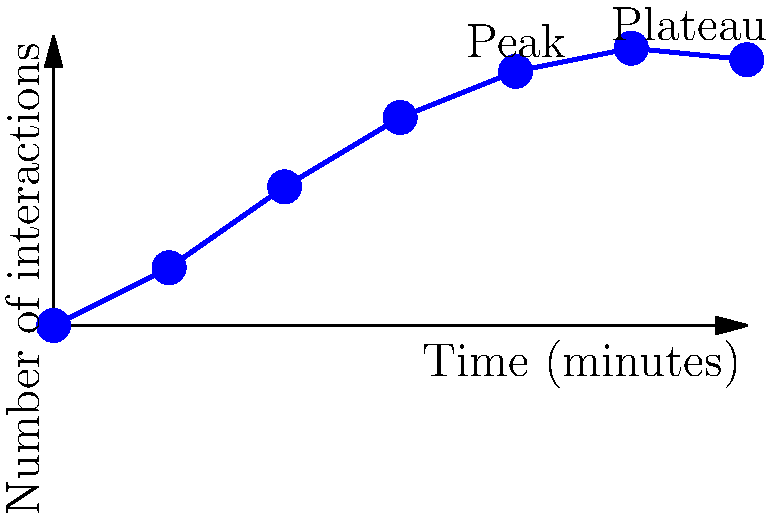Analyze the graph depicting social interactions among children in a playground over time. What psychological principle best explains the initial increase and subsequent plateau in social interactions? To answer this question, let's analyze the graph step-by-step:

1. Initial increase (0-40 minutes):
   - The number of social interactions rises rapidly from 0 to about 22.
   - This suggests children are becoming more comfortable in the environment and with each other.

2. Plateau (40-60 minutes):
   - The number of interactions stabilizes around 23-24.
   - This indicates a saturation point in social engagement.

3. Psychological principles to consider:
   a) Social facilitation: The presence of others enhances performance in familiar tasks.
   b) Adaptation level theory: People adjust to new stimuli and reach a stable state.
   c) Optimal arousal theory: There's an ideal level of stimulation for performance.

4. Best explanation:
   The optimal arousal theory best explains this pattern. It suggests that:
   - Initially, children seek out interactions to reach an optimal level of stimulation.
   - Once reached, they maintain this level, explaining the plateau.
   - Too little stimulation (beginning) or too much (if the line continued rising) would be less desirable.

5. Application to child psychology:
   - Understanding this principle helps in designing play environments and structuring playtime.
   - It suggests that children naturally regulate their social interactions to maintain an optimal level of engagement.
Answer: Optimal arousal theory 